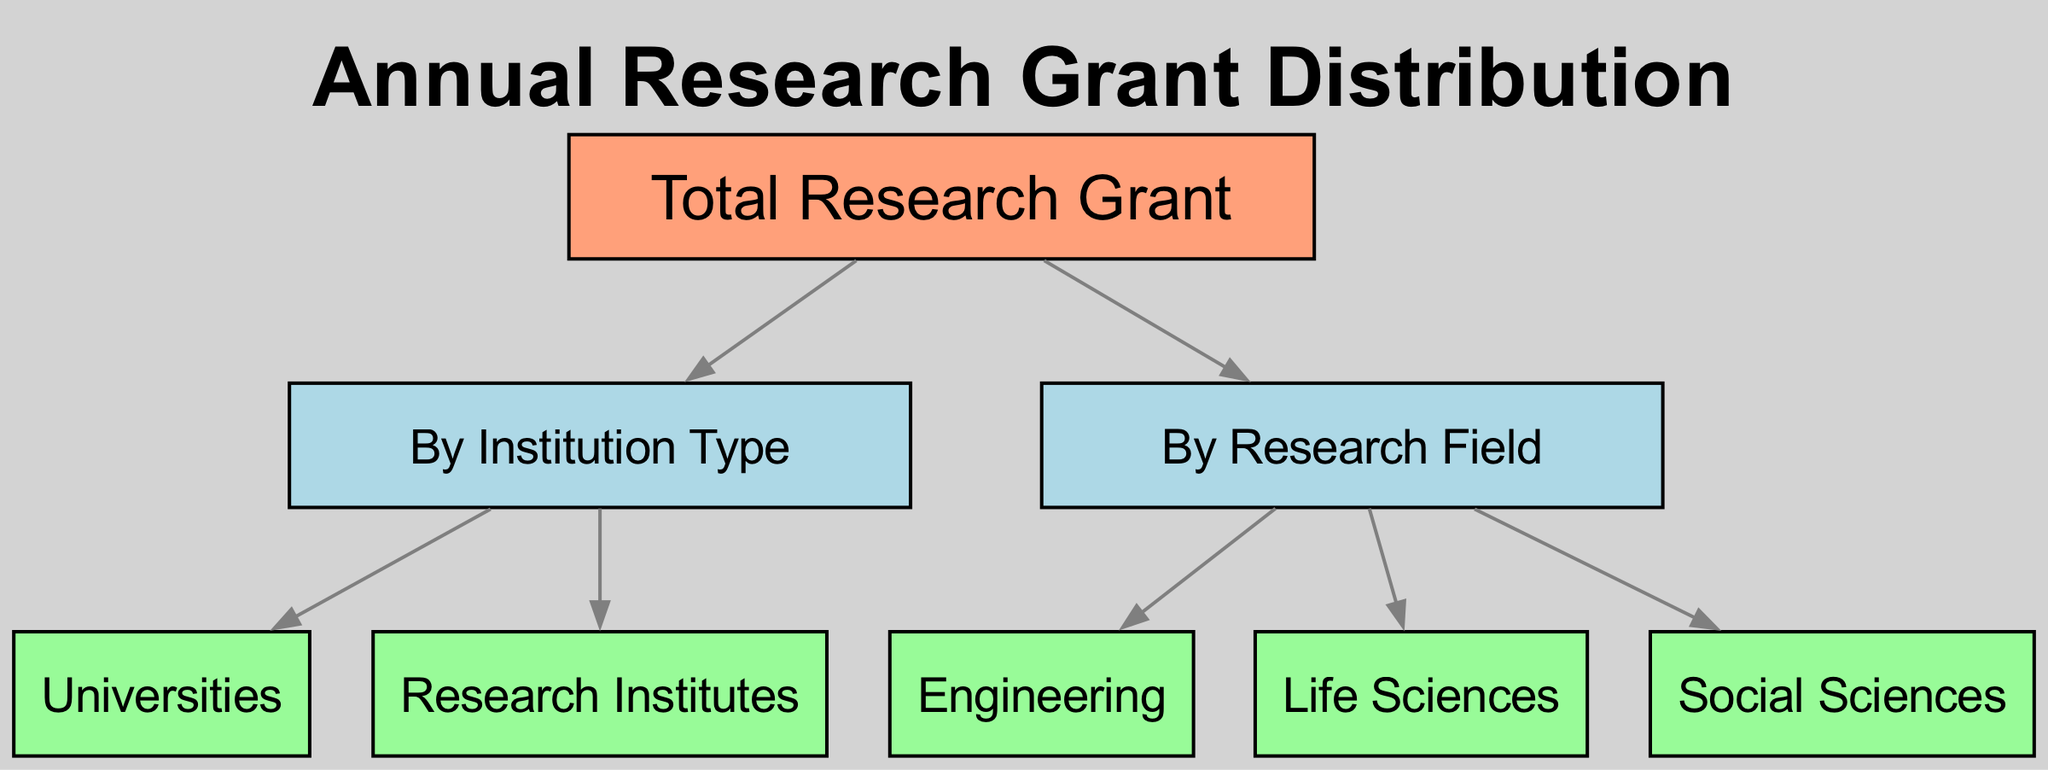What's the total number of nodes in the diagram? The diagram has nodes representing the total research grant, categories such as institution type and research field, and subcategories under those categories. Counting all the nodes carefully gives a total of 8 nodes.
Answer: 8 How many categories are shown under "By Institution Type"? There are two subcategories directly listed under "By Institution Type," which are Universities and Research Institutes.
Answer: 2 Which research field is represented as a subcategory? The diagram lists Engineering, Life Sciences, and Social Sciences as subfields under the category "By Research Field." Each of these subfields is a subcategory connected to the "By Research Field" node.
Answer: Engineering, Life Sciences, Social Sciences What is the relationship between "Total Research Grant" and "By Research Field"? The "Total Research Grant" node has a direct edge that connects it to the "By Research Field" node, indicating that the total funding is also distributed based on different research fields.
Answer: Direct connection List the types of institutions represented in the diagram. The diagram displays two types of institutions: Universities and Research Institutes, categorized under the "By Institution Type" section.
Answer: Universities, Research Institutes How many edges are there in the graph? The diagram features connections (edges) between nodes indicating relationships. Counting each connection shows there are 6 edges linking the various nodes.
Answer: 6 Which institution type has a direct link to the "Total Research Grant"? The institution types, namely Universities and Research Institutes, both have a direct edge linked to the "Total Research Grant" node, meaning they contribute to the overall funding.
Answer: Universities, Research Institutes What is the purpose of the "By Research Field" category? The purpose of the "By Research Field" category is to categorize the total research grant distribution according to various specific fields of study, such as Engineering, Life Sciences, and Social Sciences.
Answer: Categorize funding by field 